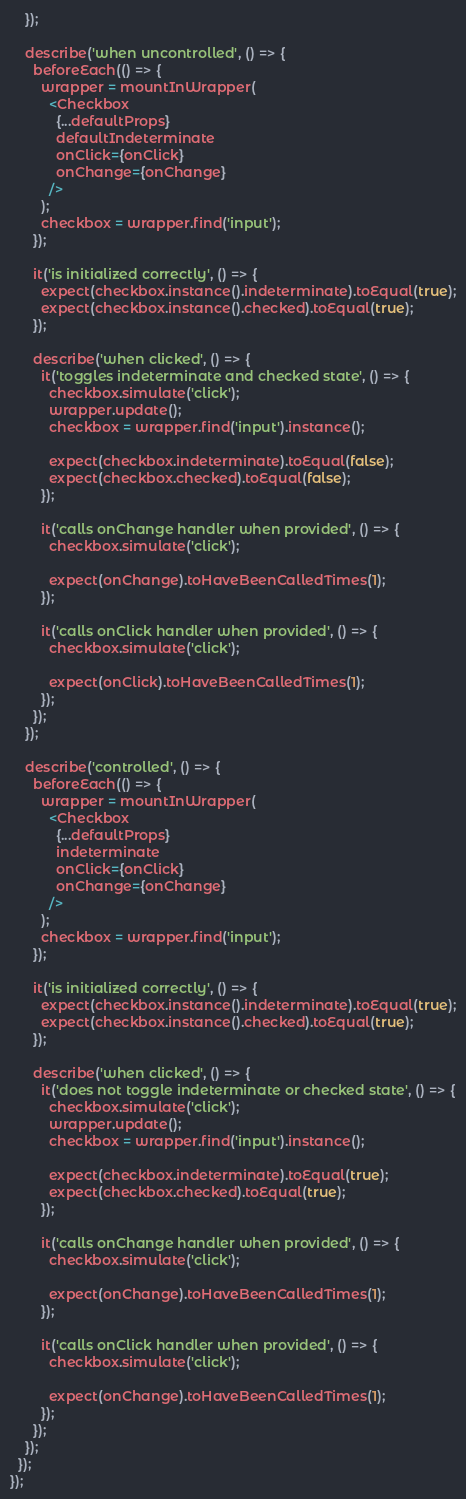<code> <loc_0><loc_0><loc_500><loc_500><_JavaScript_>    });

    describe('when uncontrolled', () => {
      beforeEach(() => {
        wrapper = mountInWrapper(
          <Checkbox
            {...defaultProps}
            defaultIndeterminate
            onClick={onClick}
            onChange={onChange}
          />
        );
        checkbox = wrapper.find('input');
      });

      it('is initialized correctly', () => {
        expect(checkbox.instance().indeterminate).toEqual(true);
        expect(checkbox.instance().checked).toEqual(true);
      });

      describe('when clicked', () => {
        it('toggles indeterminate and checked state', () => {
          checkbox.simulate('click');
          wrapper.update();
          checkbox = wrapper.find('input').instance();

          expect(checkbox.indeterminate).toEqual(false);
          expect(checkbox.checked).toEqual(false);
        });

        it('calls onChange handler when provided', () => {
          checkbox.simulate('click');

          expect(onChange).toHaveBeenCalledTimes(1);
        });

        it('calls onClick handler when provided', () => {
          checkbox.simulate('click');

          expect(onClick).toHaveBeenCalledTimes(1);
        });
      });
    });

    describe('controlled', () => {
      beforeEach(() => {
        wrapper = mountInWrapper(
          <Checkbox
            {...defaultProps}
            indeterminate
            onClick={onClick}
            onChange={onChange}
          />
        );
        checkbox = wrapper.find('input');
      });

      it('is initialized correctly', () => {
        expect(checkbox.instance().indeterminate).toEqual(true);
        expect(checkbox.instance().checked).toEqual(true);
      });

      describe('when clicked', () => {
        it('does not toggle indeterminate or checked state', () => {
          checkbox.simulate('click');
          wrapper.update();
          checkbox = wrapper.find('input').instance();

          expect(checkbox.indeterminate).toEqual(true);
          expect(checkbox.checked).toEqual(true);
        });

        it('calls onChange handler when provided', () => {
          checkbox.simulate('click');

          expect(onChange).toHaveBeenCalledTimes(1);
        });

        it('calls onClick handler when provided', () => {
          checkbox.simulate('click');

          expect(onChange).toHaveBeenCalledTimes(1);
        });
      });
    });
  });
});
</code> 